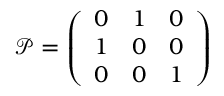<formula> <loc_0><loc_0><loc_500><loc_500>\mathcal { P } = \left ( \begin{array} { l l l } { 0 } & { 1 } & { 0 } \\ { 1 } & { 0 } & { 0 } \\ { 0 } & { 0 } & { 1 } \end{array} \right )</formula> 